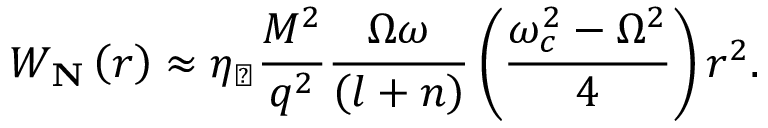Convert formula to latex. <formula><loc_0><loc_0><loc_500><loc_500>W _ { N } \left ( r \right ) \approx \eta _ { \perp } \frac { M ^ { 2 } } { q ^ { 2 } } \frac { \Omega \omega } { \left ( l + n \right ) } \left ( \frac { \omega _ { c } ^ { 2 } - \Omega ^ { 2 } } { 4 } \right ) r ^ { 2 } .</formula> 